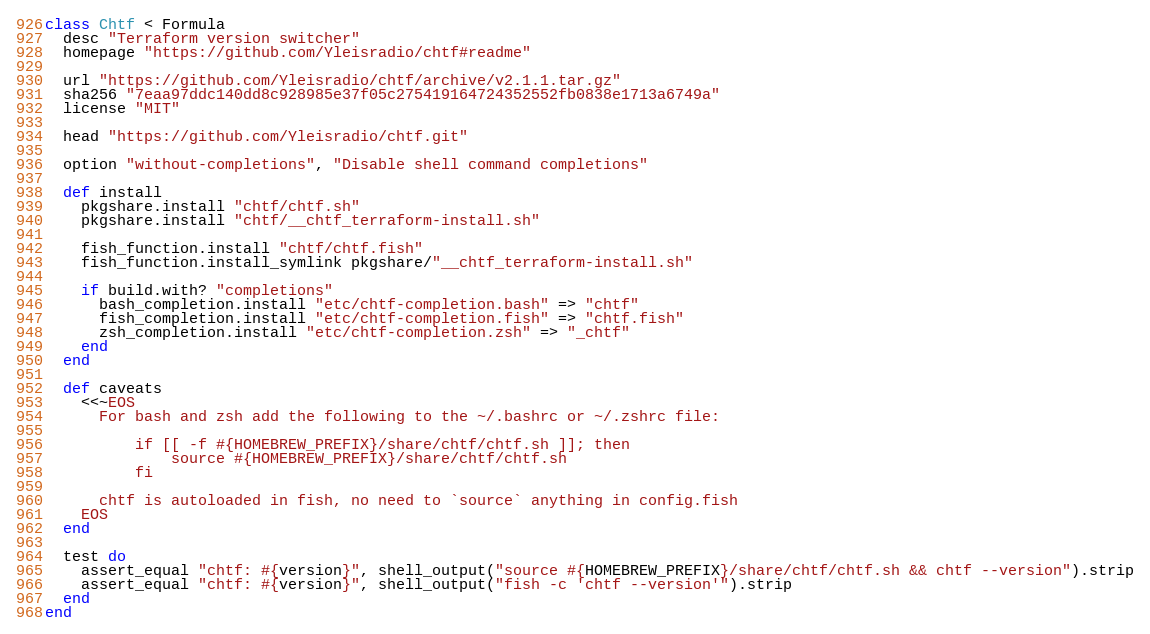Convert code to text. <code><loc_0><loc_0><loc_500><loc_500><_Ruby_>class Chtf < Formula
  desc "Terraform version switcher"
  homepage "https://github.com/Yleisradio/chtf#readme"

  url "https://github.com/Yleisradio/chtf/archive/v2.1.1.tar.gz"
  sha256 "7eaa97ddc140dd8c928985e37f05c275419164724352552fb0838e1713a6749a"
  license "MIT"

  head "https://github.com/Yleisradio/chtf.git"

  option "without-completions", "Disable shell command completions"

  def install
    pkgshare.install "chtf/chtf.sh"
    pkgshare.install "chtf/__chtf_terraform-install.sh"

    fish_function.install "chtf/chtf.fish"
    fish_function.install_symlink pkgshare/"__chtf_terraform-install.sh"

    if build.with? "completions"
      bash_completion.install "etc/chtf-completion.bash" => "chtf"
      fish_completion.install "etc/chtf-completion.fish" => "chtf.fish"
      zsh_completion.install "etc/chtf-completion.zsh" => "_chtf"
    end
  end

  def caveats
    <<~EOS
      For bash and zsh add the following to the ~/.bashrc or ~/.zshrc file:

          if [[ -f #{HOMEBREW_PREFIX}/share/chtf/chtf.sh ]]; then
              source #{HOMEBREW_PREFIX}/share/chtf/chtf.sh
          fi

      chtf is autoloaded in fish, no need to `source` anything in config.fish
    EOS
  end

  test do
    assert_equal "chtf: #{version}", shell_output("source #{HOMEBREW_PREFIX}/share/chtf/chtf.sh && chtf --version").strip
    assert_equal "chtf: #{version}", shell_output("fish -c 'chtf --version'").strip
  end
end
</code> 